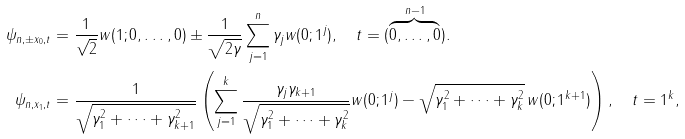<formula> <loc_0><loc_0><loc_500><loc_500>\psi _ { n , \pm x _ { 0 } , t } & = \frac { 1 } { \sqrt { 2 } } w ( 1 ; 0 , \dots , 0 ) \pm \frac { 1 } { \sqrt { 2 \gamma } } \sum _ { j = 1 } ^ { n } \gamma _ { j } w ( 0 ; 1 ^ { j } ) , \quad t = ( \overbrace { 0 , \dots , 0 } ^ { n - 1 } ) . \\ \psi _ { n , x _ { 1 } , t } & = \frac { 1 } { \sqrt { \gamma _ { 1 } ^ { 2 } + \cdots + \gamma _ { k + 1 } ^ { 2 } } } \left ( \sum _ { j = 1 } ^ { k } \frac { \gamma _ { j } \gamma _ { k + 1 } } { \sqrt { \gamma _ { 1 } ^ { 2 } + \cdots + \gamma _ { k } ^ { 2 } } } w ( 0 ; 1 ^ { j } ) - \sqrt { \gamma _ { 1 } ^ { 2 } + \cdots + \gamma _ { k } ^ { 2 } } \, w ( 0 ; 1 ^ { k + 1 } ) \right ) , \quad t = 1 ^ { k } ,</formula> 